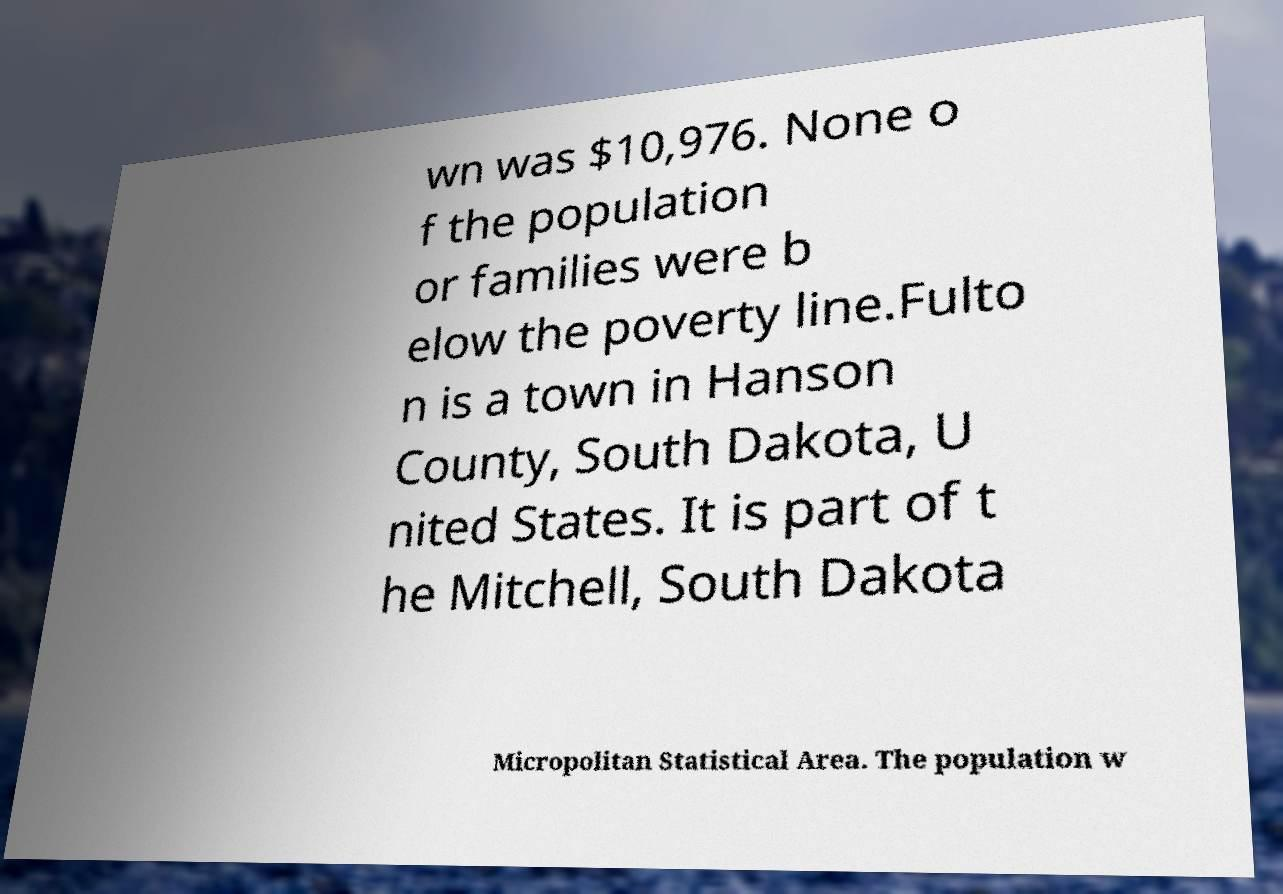Could you extract and type out the text from this image? wn was $10,976. None o f the population or families were b elow the poverty line.Fulto n is a town in Hanson County, South Dakota, U nited States. It is part of t he Mitchell, South Dakota Micropolitan Statistical Area. The population w 